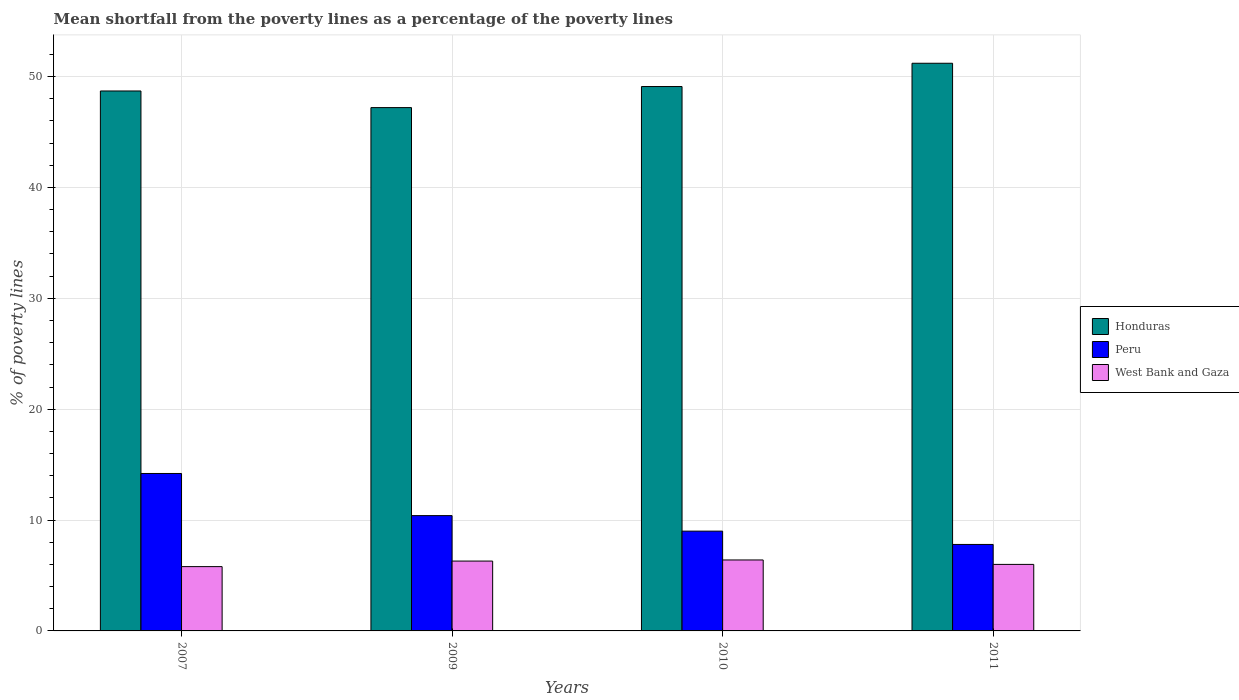How many different coloured bars are there?
Offer a very short reply. 3. How many groups of bars are there?
Make the answer very short. 4. Are the number of bars on each tick of the X-axis equal?
Offer a terse response. Yes. Across all years, what is the maximum mean shortfall from the poverty lines as a percentage of the poverty lines in West Bank and Gaza?
Your response must be concise. 6.4. In which year was the mean shortfall from the poverty lines as a percentage of the poverty lines in West Bank and Gaza minimum?
Offer a very short reply. 2007. What is the difference between the mean shortfall from the poverty lines as a percentage of the poverty lines in West Bank and Gaza in 2010 and that in 2011?
Provide a short and direct response. 0.4. What is the difference between the mean shortfall from the poverty lines as a percentage of the poverty lines in West Bank and Gaza in 2011 and the mean shortfall from the poverty lines as a percentage of the poverty lines in Honduras in 2009?
Ensure brevity in your answer.  -41.2. What is the average mean shortfall from the poverty lines as a percentage of the poverty lines in Peru per year?
Make the answer very short. 10.35. In the year 2010, what is the difference between the mean shortfall from the poverty lines as a percentage of the poverty lines in Honduras and mean shortfall from the poverty lines as a percentage of the poverty lines in West Bank and Gaza?
Your answer should be very brief. 42.7. What is the ratio of the mean shortfall from the poverty lines as a percentage of the poverty lines in West Bank and Gaza in 2009 to that in 2010?
Your response must be concise. 0.98. Is the mean shortfall from the poverty lines as a percentage of the poverty lines in Peru in 2007 less than that in 2010?
Offer a terse response. No. What is the difference between the highest and the second highest mean shortfall from the poverty lines as a percentage of the poverty lines in Honduras?
Provide a succinct answer. 2.1. What is the difference between the highest and the lowest mean shortfall from the poverty lines as a percentage of the poverty lines in Peru?
Give a very brief answer. 6.4. In how many years, is the mean shortfall from the poverty lines as a percentage of the poverty lines in Peru greater than the average mean shortfall from the poverty lines as a percentage of the poverty lines in Peru taken over all years?
Offer a terse response. 2. What does the 1st bar from the left in 2011 represents?
Your answer should be very brief. Honduras. Is it the case that in every year, the sum of the mean shortfall from the poverty lines as a percentage of the poverty lines in Honduras and mean shortfall from the poverty lines as a percentage of the poverty lines in Peru is greater than the mean shortfall from the poverty lines as a percentage of the poverty lines in West Bank and Gaza?
Provide a succinct answer. Yes. Are all the bars in the graph horizontal?
Offer a terse response. No. How many years are there in the graph?
Offer a terse response. 4. Are the values on the major ticks of Y-axis written in scientific E-notation?
Ensure brevity in your answer.  No. Where does the legend appear in the graph?
Make the answer very short. Center right. What is the title of the graph?
Make the answer very short. Mean shortfall from the poverty lines as a percentage of the poverty lines. What is the label or title of the X-axis?
Offer a terse response. Years. What is the label or title of the Y-axis?
Give a very brief answer. % of poverty lines. What is the % of poverty lines in Honduras in 2007?
Your response must be concise. 48.7. What is the % of poverty lines in Peru in 2007?
Provide a succinct answer. 14.2. What is the % of poverty lines of Honduras in 2009?
Provide a short and direct response. 47.2. What is the % of poverty lines in Peru in 2009?
Offer a terse response. 10.4. What is the % of poverty lines in West Bank and Gaza in 2009?
Provide a succinct answer. 6.3. What is the % of poverty lines in Honduras in 2010?
Keep it short and to the point. 49.1. What is the % of poverty lines of Honduras in 2011?
Your answer should be compact. 51.2. What is the % of poverty lines of Peru in 2011?
Keep it short and to the point. 7.8. What is the % of poverty lines in West Bank and Gaza in 2011?
Provide a short and direct response. 6. Across all years, what is the maximum % of poverty lines in Honduras?
Give a very brief answer. 51.2. Across all years, what is the maximum % of poverty lines of West Bank and Gaza?
Ensure brevity in your answer.  6.4. Across all years, what is the minimum % of poverty lines in Honduras?
Ensure brevity in your answer.  47.2. Across all years, what is the minimum % of poverty lines in Peru?
Keep it short and to the point. 7.8. Across all years, what is the minimum % of poverty lines in West Bank and Gaza?
Your answer should be compact. 5.8. What is the total % of poverty lines in Honduras in the graph?
Offer a very short reply. 196.2. What is the total % of poverty lines in Peru in the graph?
Keep it short and to the point. 41.4. What is the total % of poverty lines in West Bank and Gaza in the graph?
Give a very brief answer. 24.5. What is the difference between the % of poverty lines in Honduras in 2007 and that in 2009?
Your answer should be very brief. 1.5. What is the difference between the % of poverty lines in West Bank and Gaza in 2007 and that in 2009?
Keep it short and to the point. -0.5. What is the difference between the % of poverty lines in Peru in 2007 and that in 2010?
Your response must be concise. 5.2. What is the difference between the % of poverty lines of West Bank and Gaza in 2007 and that in 2010?
Provide a succinct answer. -0.6. What is the difference between the % of poverty lines in Peru in 2007 and that in 2011?
Your answer should be very brief. 6.4. What is the difference between the % of poverty lines in West Bank and Gaza in 2007 and that in 2011?
Your answer should be compact. -0.2. What is the difference between the % of poverty lines in Honduras in 2009 and that in 2010?
Keep it short and to the point. -1.9. What is the difference between the % of poverty lines of West Bank and Gaza in 2009 and that in 2010?
Offer a terse response. -0.1. What is the difference between the % of poverty lines in Honduras in 2009 and that in 2011?
Give a very brief answer. -4. What is the difference between the % of poverty lines of Honduras in 2010 and that in 2011?
Provide a short and direct response. -2.1. What is the difference between the % of poverty lines in West Bank and Gaza in 2010 and that in 2011?
Your response must be concise. 0.4. What is the difference between the % of poverty lines in Honduras in 2007 and the % of poverty lines in Peru in 2009?
Ensure brevity in your answer.  38.3. What is the difference between the % of poverty lines of Honduras in 2007 and the % of poverty lines of West Bank and Gaza in 2009?
Your answer should be compact. 42.4. What is the difference between the % of poverty lines in Honduras in 2007 and the % of poverty lines in Peru in 2010?
Provide a succinct answer. 39.7. What is the difference between the % of poverty lines in Honduras in 2007 and the % of poverty lines in West Bank and Gaza in 2010?
Ensure brevity in your answer.  42.3. What is the difference between the % of poverty lines of Honduras in 2007 and the % of poverty lines of Peru in 2011?
Ensure brevity in your answer.  40.9. What is the difference between the % of poverty lines of Honduras in 2007 and the % of poverty lines of West Bank and Gaza in 2011?
Make the answer very short. 42.7. What is the difference between the % of poverty lines of Honduras in 2009 and the % of poverty lines of Peru in 2010?
Ensure brevity in your answer.  38.2. What is the difference between the % of poverty lines in Honduras in 2009 and the % of poverty lines in West Bank and Gaza in 2010?
Give a very brief answer. 40.8. What is the difference between the % of poverty lines of Honduras in 2009 and the % of poverty lines of Peru in 2011?
Make the answer very short. 39.4. What is the difference between the % of poverty lines in Honduras in 2009 and the % of poverty lines in West Bank and Gaza in 2011?
Offer a terse response. 41.2. What is the difference between the % of poverty lines of Peru in 2009 and the % of poverty lines of West Bank and Gaza in 2011?
Give a very brief answer. 4.4. What is the difference between the % of poverty lines of Honduras in 2010 and the % of poverty lines of Peru in 2011?
Provide a succinct answer. 41.3. What is the difference between the % of poverty lines of Honduras in 2010 and the % of poverty lines of West Bank and Gaza in 2011?
Your answer should be compact. 43.1. What is the difference between the % of poverty lines of Peru in 2010 and the % of poverty lines of West Bank and Gaza in 2011?
Offer a terse response. 3. What is the average % of poverty lines in Honduras per year?
Ensure brevity in your answer.  49.05. What is the average % of poverty lines in Peru per year?
Provide a succinct answer. 10.35. What is the average % of poverty lines of West Bank and Gaza per year?
Your response must be concise. 6.12. In the year 2007, what is the difference between the % of poverty lines in Honduras and % of poverty lines in Peru?
Make the answer very short. 34.5. In the year 2007, what is the difference between the % of poverty lines in Honduras and % of poverty lines in West Bank and Gaza?
Provide a short and direct response. 42.9. In the year 2009, what is the difference between the % of poverty lines of Honduras and % of poverty lines of Peru?
Offer a very short reply. 36.8. In the year 2009, what is the difference between the % of poverty lines in Honduras and % of poverty lines in West Bank and Gaza?
Your response must be concise. 40.9. In the year 2009, what is the difference between the % of poverty lines of Peru and % of poverty lines of West Bank and Gaza?
Provide a short and direct response. 4.1. In the year 2010, what is the difference between the % of poverty lines in Honduras and % of poverty lines in Peru?
Offer a terse response. 40.1. In the year 2010, what is the difference between the % of poverty lines in Honduras and % of poverty lines in West Bank and Gaza?
Provide a succinct answer. 42.7. In the year 2011, what is the difference between the % of poverty lines in Honduras and % of poverty lines in Peru?
Your answer should be compact. 43.4. In the year 2011, what is the difference between the % of poverty lines of Honduras and % of poverty lines of West Bank and Gaza?
Give a very brief answer. 45.2. What is the ratio of the % of poverty lines of Honduras in 2007 to that in 2009?
Your answer should be compact. 1.03. What is the ratio of the % of poverty lines of Peru in 2007 to that in 2009?
Offer a terse response. 1.37. What is the ratio of the % of poverty lines of West Bank and Gaza in 2007 to that in 2009?
Provide a succinct answer. 0.92. What is the ratio of the % of poverty lines in Honduras in 2007 to that in 2010?
Your response must be concise. 0.99. What is the ratio of the % of poverty lines of Peru in 2007 to that in 2010?
Ensure brevity in your answer.  1.58. What is the ratio of the % of poverty lines in West Bank and Gaza in 2007 to that in 2010?
Your answer should be compact. 0.91. What is the ratio of the % of poverty lines of Honduras in 2007 to that in 2011?
Keep it short and to the point. 0.95. What is the ratio of the % of poverty lines of Peru in 2007 to that in 2011?
Offer a terse response. 1.82. What is the ratio of the % of poverty lines of West Bank and Gaza in 2007 to that in 2011?
Provide a succinct answer. 0.97. What is the ratio of the % of poverty lines of Honduras in 2009 to that in 2010?
Make the answer very short. 0.96. What is the ratio of the % of poverty lines in Peru in 2009 to that in 2010?
Offer a very short reply. 1.16. What is the ratio of the % of poverty lines in West Bank and Gaza in 2009 to that in 2010?
Keep it short and to the point. 0.98. What is the ratio of the % of poverty lines in Honduras in 2009 to that in 2011?
Keep it short and to the point. 0.92. What is the ratio of the % of poverty lines in Peru in 2009 to that in 2011?
Provide a succinct answer. 1.33. What is the ratio of the % of poverty lines of West Bank and Gaza in 2009 to that in 2011?
Keep it short and to the point. 1.05. What is the ratio of the % of poverty lines in Honduras in 2010 to that in 2011?
Offer a very short reply. 0.96. What is the ratio of the % of poverty lines of Peru in 2010 to that in 2011?
Keep it short and to the point. 1.15. What is the ratio of the % of poverty lines of West Bank and Gaza in 2010 to that in 2011?
Give a very brief answer. 1.07. What is the difference between the highest and the second highest % of poverty lines in Honduras?
Provide a succinct answer. 2.1. What is the difference between the highest and the second highest % of poverty lines of West Bank and Gaza?
Give a very brief answer. 0.1. What is the difference between the highest and the lowest % of poverty lines in Honduras?
Provide a short and direct response. 4. 